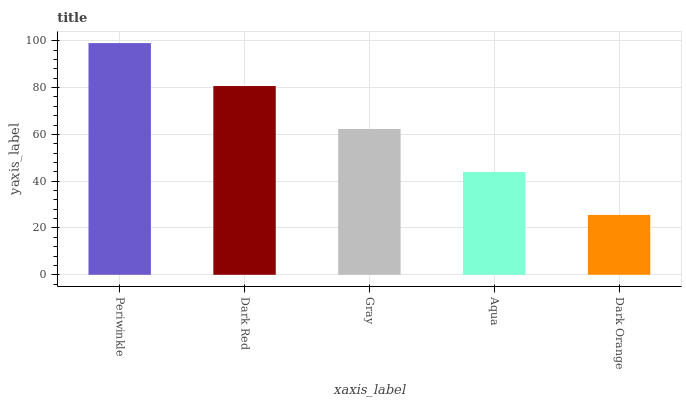Is Dark Orange the minimum?
Answer yes or no. Yes. Is Periwinkle the maximum?
Answer yes or no. Yes. Is Dark Red the minimum?
Answer yes or no. No. Is Dark Red the maximum?
Answer yes or no. No. Is Periwinkle greater than Dark Red?
Answer yes or no. Yes. Is Dark Red less than Periwinkle?
Answer yes or no. Yes. Is Dark Red greater than Periwinkle?
Answer yes or no. No. Is Periwinkle less than Dark Red?
Answer yes or no. No. Is Gray the high median?
Answer yes or no. Yes. Is Gray the low median?
Answer yes or no. Yes. Is Aqua the high median?
Answer yes or no. No. Is Dark Orange the low median?
Answer yes or no. No. 